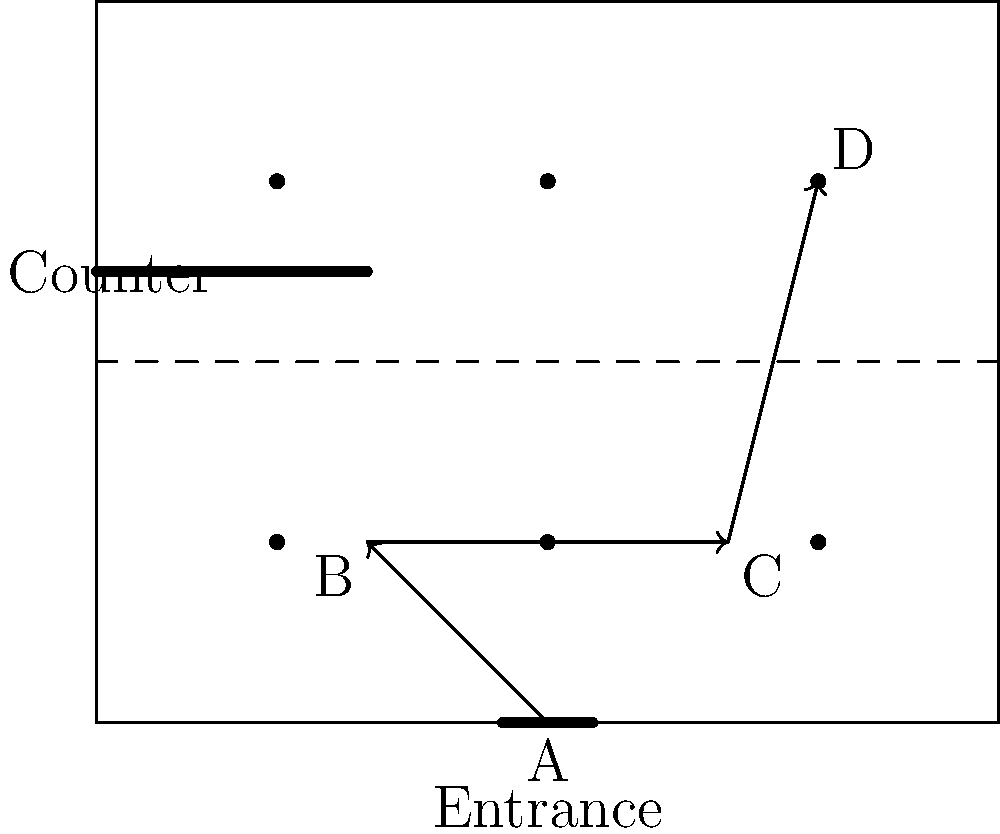In the cafe layout shown, customer movement is represented by vectors. A customer enters at point A, moves to point B, then to C, and finally to D. If each unit in the layout represents 1 meter, calculate the total distance traveled by the customer using vector addition. Round your answer to the nearest tenth of a meter. To solve this problem, we need to follow these steps:

1. Identify the vectors:
   $\vec{AB}$, $\vec{BC}$, and $\vec{CD}$

2. Calculate each vector:
   $\vec{AB} = (3-5, 2-0) = (-2, 2)$
   $\vec{BC} = (7-3, 2-2) = (4, 0)$
   $\vec{CD} = (8-7, 6-2) = (1, 4)$

3. Calculate the magnitude (length) of each vector using the formula $\sqrt{x^2 + y^2}$:
   $|\vec{AB}| = \sqrt{(-2)^2 + 2^2} = \sqrt{8} \approx 2.8$ meters
   $|\vec{BC}| = \sqrt{4^2 + 0^2} = 4$ meters
   $|\vec{CD}| = \sqrt{1^2 + 4^2} = \sqrt{17} \approx 4.1$ meters

4. Sum the magnitudes:
   Total distance = $|\vec{AB}| + |\vec{BC}| + |\vec{CD}|$
                  $\approx 2.8 + 4 + 4.1 = 10.9$ meters

5. Round to the nearest tenth:
   10.9 meters
Answer: 10.9 meters 